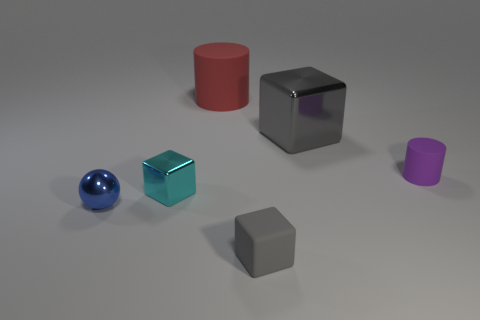The other object that is the same color as the large metal thing is what shape?
Your answer should be very brief. Cube. Is the number of metal blocks less than the number of small rubber cylinders?
Give a very brief answer. No. Is there anything else of the same color as the large matte thing?
Provide a short and direct response. No. There is a purple object that is the same material as the large red object; what is its shape?
Your answer should be compact. Cylinder. How many gray cubes are in front of the rubber cylinder on the right side of the gray cube behind the cyan thing?
Make the answer very short. 1. There is a thing that is both on the right side of the small gray cube and left of the small rubber cylinder; what is its shape?
Your response must be concise. Cube. Are there fewer small blue metallic balls that are to the right of the rubber block than small balls?
Provide a succinct answer. Yes. What number of tiny things are either metal balls or purple rubber objects?
Ensure brevity in your answer.  2. The cyan cube has what size?
Offer a very short reply. Small. Is there anything else that is the same material as the red cylinder?
Your answer should be very brief. Yes. 